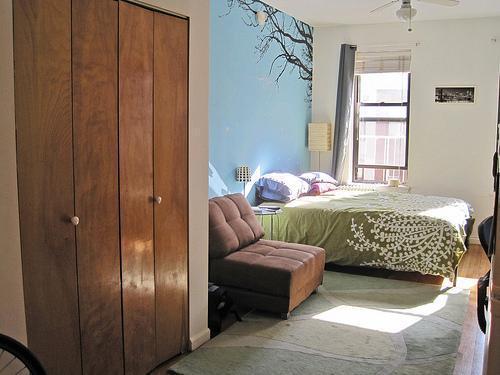How many rugs are visible?
Give a very brief answer. 1. 